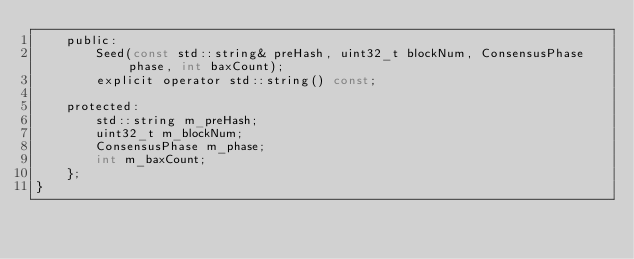Convert code to text. <code><loc_0><loc_0><loc_500><loc_500><_C_>    public:
        Seed(const std::string& preHash, uint32_t blockNum, ConsensusPhase phase, int baxCount);
        explicit operator std::string() const;

    protected:
        std::string m_preHash;
        uint32_t m_blockNum;
        ConsensusPhase m_phase;
        int m_baxCount;
    };
}</code> 